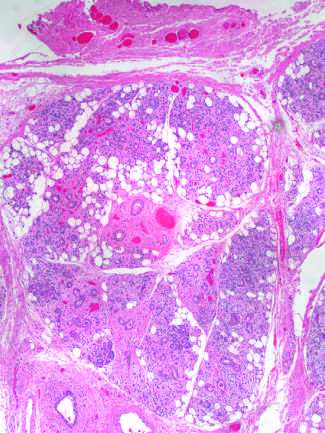how is vascular changes and fibrosis of salivary glands produced?
Answer the question using a single word or phrase. By radiation therapy of the neck region 